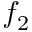Convert formula to latex. <formula><loc_0><loc_0><loc_500><loc_500>f _ { 2 }</formula> 